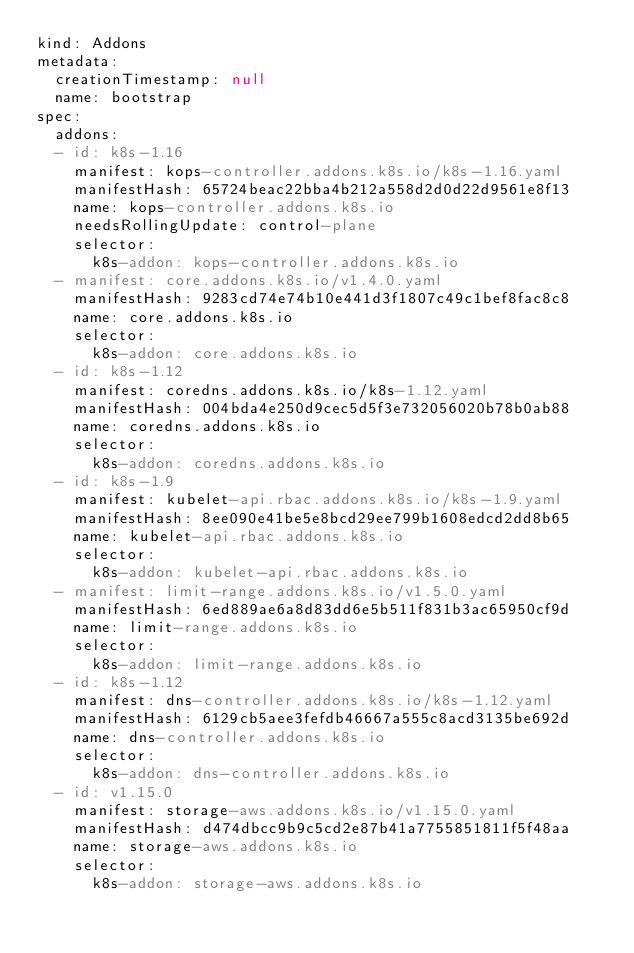<code> <loc_0><loc_0><loc_500><loc_500><_YAML_>kind: Addons
metadata:
  creationTimestamp: null
  name: bootstrap
spec:
  addons:
  - id: k8s-1.16
    manifest: kops-controller.addons.k8s.io/k8s-1.16.yaml
    manifestHash: 65724beac22bba4b212a558d2d0d22d9561e8f13
    name: kops-controller.addons.k8s.io
    needsRollingUpdate: control-plane
    selector:
      k8s-addon: kops-controller.addons.k8s.io
  - manifest: core.addons.k8s.io/v1.4.0.yaml
    manifestHash: 9283cd74e74b10e441d3f1807c49c1bef8fac8c8
    name: core.addons.k8s.io
    selector:
      k8s-addon: core.addons.k8s.io
  - id: k8s-1.12
    manifest: coredns.addons.k8s.io/k8s-1.12.yaml
    manifestHash: 004bda4e250d9cec5d5f3e732056020b78b0ab88
    name: coredns.addons.k8s.io
    selector:
      k8s-addon: coredns.addons.k8s.io
  - id: k8s-1.9
    manifest: kubelet-api.rbac.addons.k8s.io/k8s-1.9.yaml
    manifestHash: 8ee090e41be5e8bcd29ee799b1608edcd2dd8b65
    name: kubelet-api.rbac.addons.k8s.io
    selector:
      k8s-addon: kubelet-api.rbac.addons.k8s.io
  - manifest: limit-range.addons.k8s.io/v1.5.0.yaml
    manifestHash: 6ed889ae6a8d83dd6e5b511f831b3ac65950cf9d
    name: limit-range.addons.k8s.io
    selector:
      k8s-addon: limit-range.addons.k8s.io
  - id: k8s-1.12
    manifest: dns-controller.addons.k8s.io/k8s-1.12.yaml
    manifestHash: 6129cb5aee3fefdb46667a555c8acd3135be692d
    name: dns-controller.addons.k8s.io
    selector:
      k8s-addon: dns-controller.addons.k8s.io
  - id: v1.15.0
    manifest: storage-aws.addons.k8s.io/v1.15.0.yaml
    manifestHash: d474dbcc9b9c5cd2e87b41a7755851811f5f48aa
    name: storage-aws.addons.k8s.io
    selector:
      k8s-addon: storage-aws.addons.k8s.io
</code> 